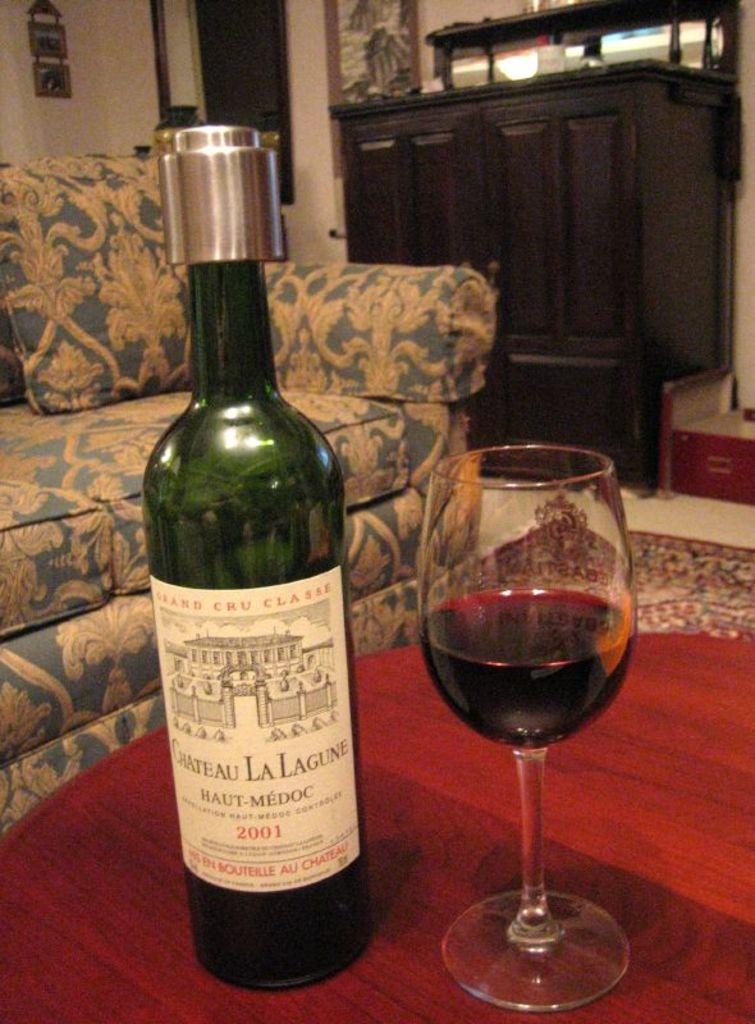Provide a one-sentence caption for the provided image. A bottle of Chateau La Lagune sits on a table next to a glass of wine. 